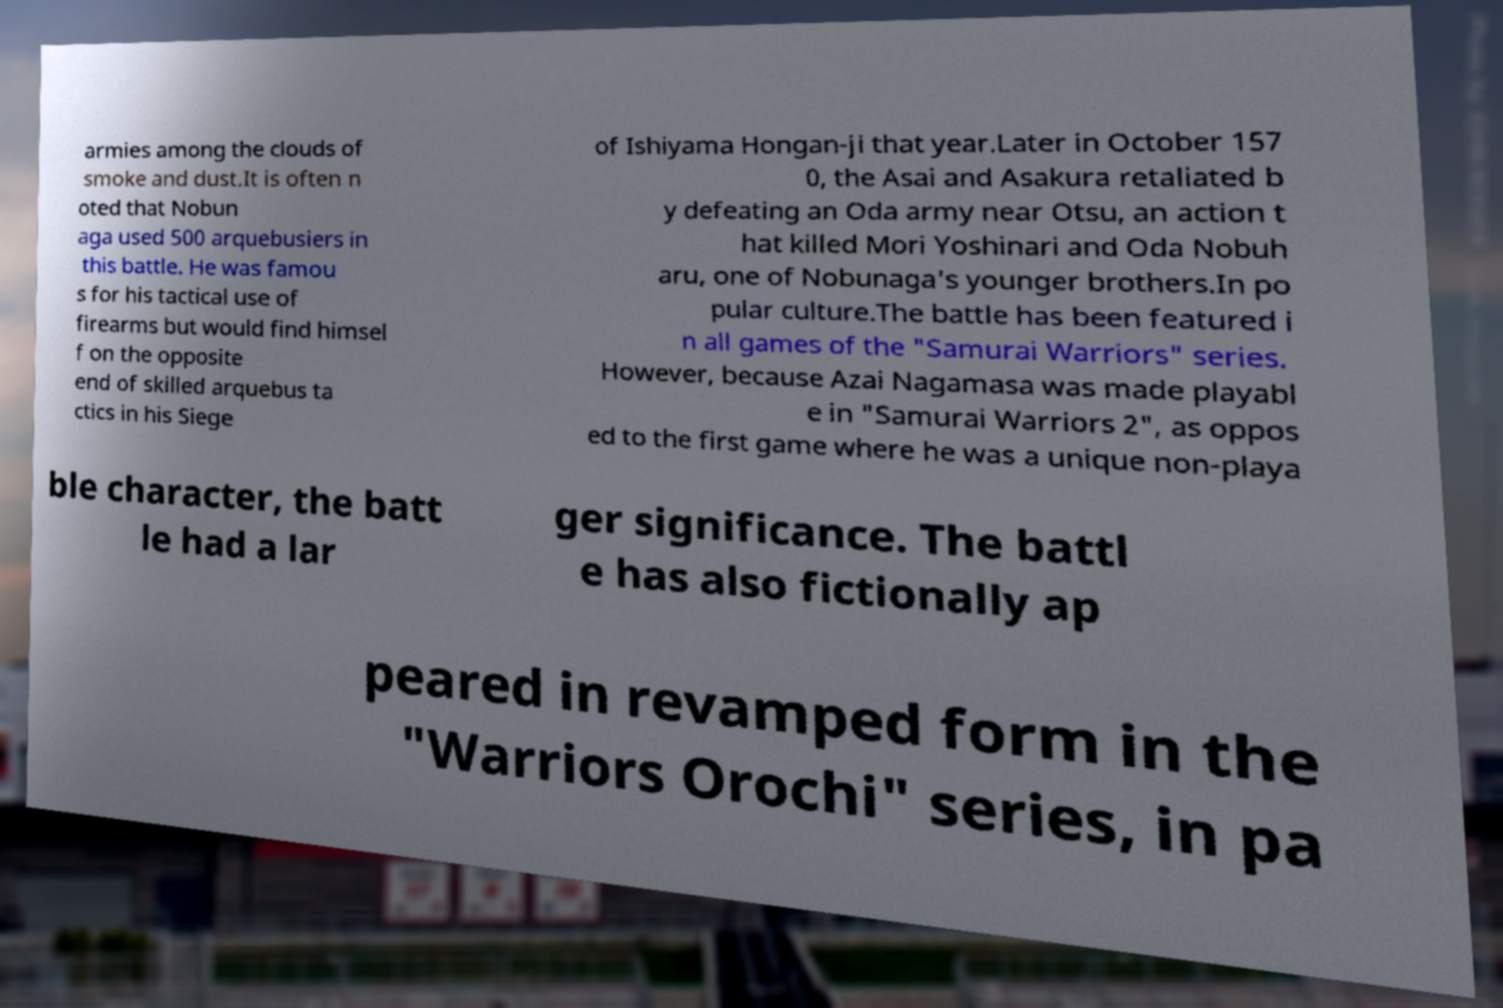There's text embedded in this image that I need extracted. Can you transcribe it verbatim? armies among the clouds of smoke and dust.It is often n oted that Nobun aga used 500 arquebusiers in this battle. He was famou s for his tactical use of firearms but would find himsel f on the opposite end of skilled arquebus ta ctics in his Siege of Ishiyama Hongan-ji that year.Later in October 157 0, the Asai and Asakura retaliated b y defeating an Oda army near Otsu, an action t hat killed Mori Yoshinari and Oda Nobuh aru, one of Nobunaga's younger brothers.In po pular culture.The battle has been featured i n all games of the "Samurai Warriors" series. However, because Azai Nagamasa was made playabl e in "Samurai Warriors 2", as oppos ed to the first game where he was a unique non-playa ble character, the batt le had a lar ger significance. The battl e has also fictionally ap peared in revamped form in the "Warriors Orochi" series, in pa 